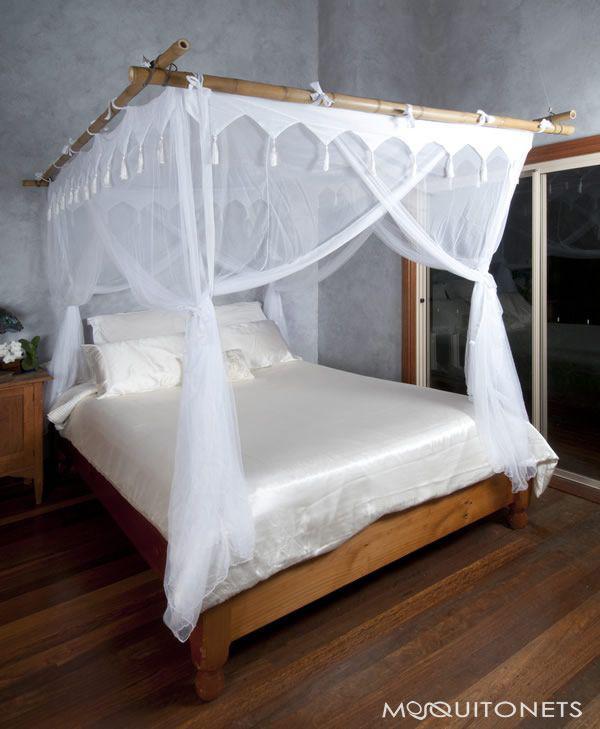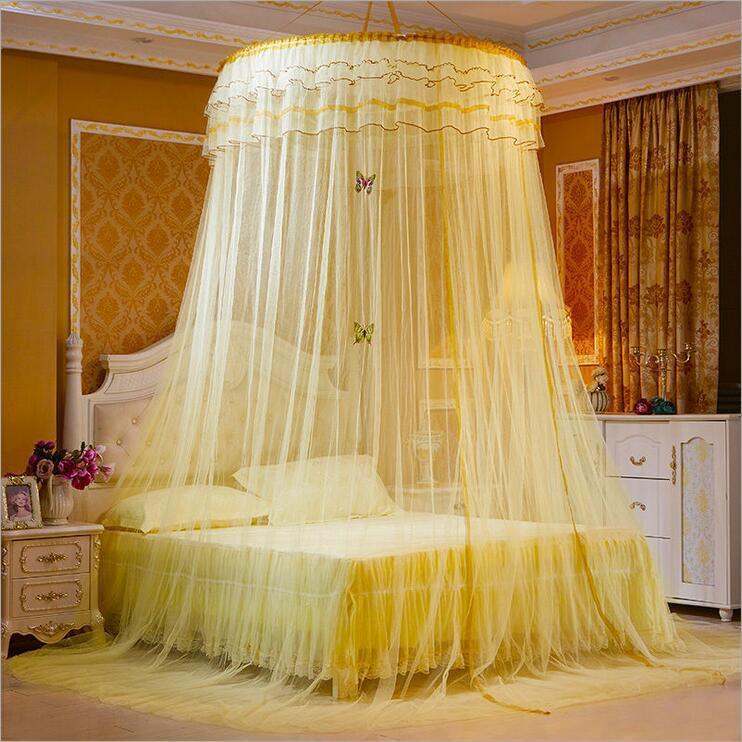The first image is the image on the left, the second image is the image on the right. Evaluate the accuracy of this statement regarding the images: "There are two circle canopies.". Is it true? Answer yes or no. No. The first image is the image on the left, the second image is the image on the right. For the images displayed, is the sentence "There are two round canopies." factually correct? Answer yes or no. No. 